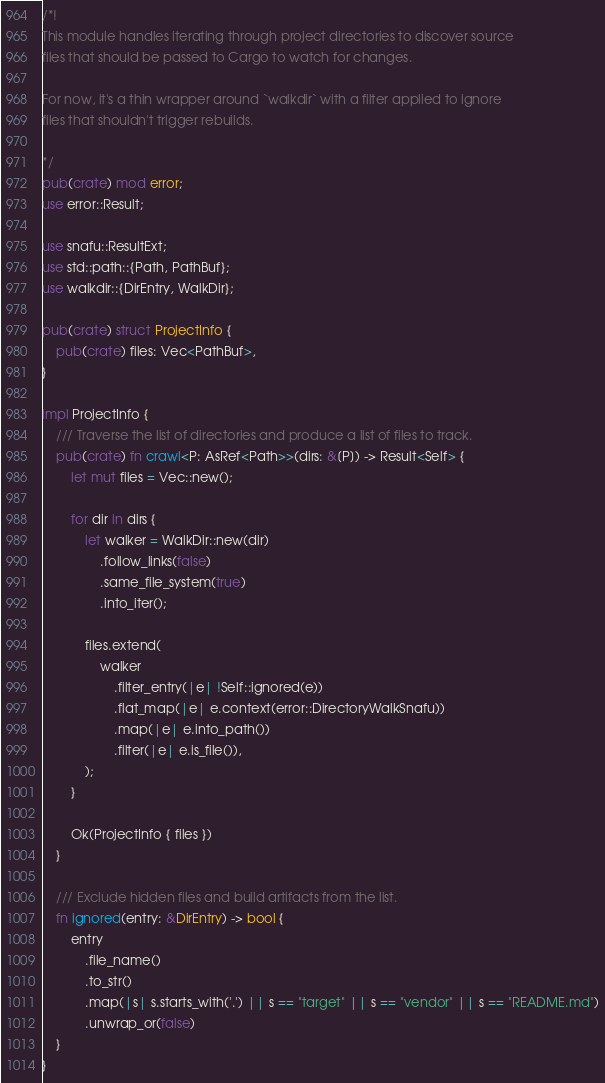Convert code to text. <code><loc_0><loc_0><loc_500><loc_500><_Rust_>/*!
This module handles iterating through project directories to discover source
files that should be passed to Cargo to watch for changes.

For now, it's a thin wrapper around `walkdir` with a filter applied to ignore
files that shouldn't trigger rebuilds.

*/
pub(crate) mod error;
use error::Result;

use snafu::ResultExt;
use std::path::{Path, PathBuf};
use walkdir::{DirEntry, WalkDir};

pub(crate) struct ProjectInfo {
    pub(crate) files: Vec<PathBuf>,
}

impl ProjectInfo {
    /// Traverse the list of directories and produce a list of files to track.
    pub(crate) fn crawl<P: AsRef<Path>>(dirs: &[P]) -> Result<Self> {
        let mut files = Vec::new();

        for dir in dirs {
            let walker = WalkDir::new(dir)
                .follow_links(false)
                .same_file_system(true)
                .into_iter();

            files.extend(
                walker
                    .filter_entry(|e| !Self::ignored(e))
                    .flat_map(|e| e.context(error::DirectoryWalkSnafu))
                    .map(|e| e.into_path())
                    .filter(|e| e.is_file()),
            );
        }

        Ok(ProjectInfo { files })
    }

    /// Exclude hidden files and build artifacts from the list.
    fn ignored(entry: &DirEntry) -> bool {
        entry
            .file_name()
            .to_str()
            .map(|s| s.starts_with('.') || s == "target" || s == "vendor" || s == "README.md")
            .unwrap_or(false)
    }
}
</code> 